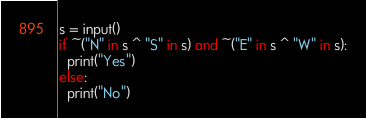<code> <loc_0><loc_0><loc_500><loc_500><_Python_>s = input()
if ~("N" in s ^ "S" in s) and ~("E" in s ^ "W" in s):
  print("Yes")
else:
  print("No")</code> 